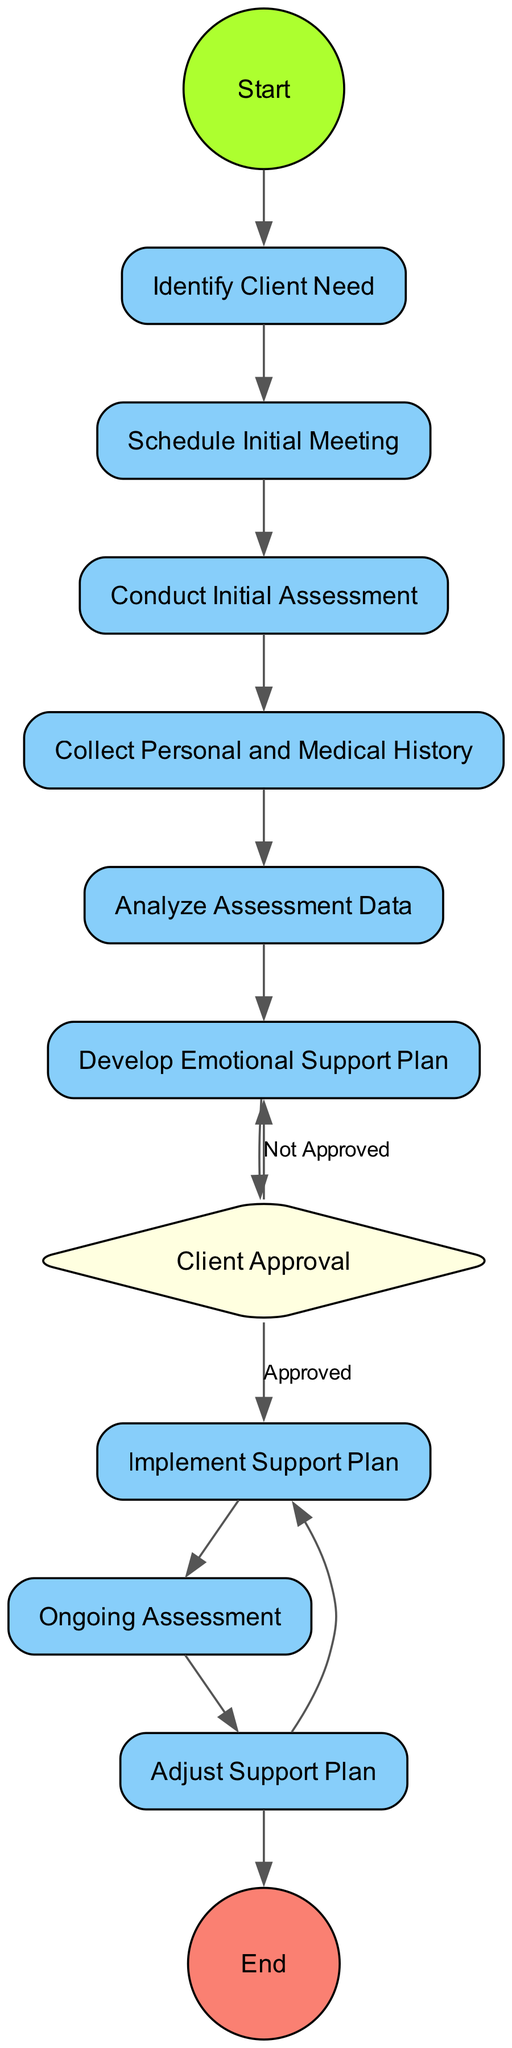What is the first activity in the diagram? The first activity listed in the diagram is "Identify Client Need," which begins the entire process of initial client assessment and emotional support planning.
Answer: Identify Client Need How many action nodes are in the diagram? The diagram contains seven action nodes, which include tasks like scheduling a meeting, conducting assessments, and developing support plans, among others.
Answer: Seven What decision occurs after developing the emotional support plan? After developing the emotional support plan, the decision that occurs is "Client Approval," where the client's consent for the plan is discussed.
Answer: Client Approval What happens if the client does not approve the emotional support plan? If the client does not approve the emotional support plan, the process transitions back to "Develop Emotional Support Plan," where adjustments can be made according to client feedback.
Answer: Develop Emotional Support Plan What activity follows "Ongoing Assessment"? After "Ongoing Assessment," the next activity is "Adjust Support Plan," which indicates that modifications to the support plan are made based on the client's progress.
Answer: Adjust Support Plan What collection of information is done before analyzing assessment data? Before analyzing assessment data, the activity "Collect Personal and Medical History" is performed to gather relevant background information necessary for the analysis.
Answer: Collect Personal and Medical History Which activity leads to implementing the support plan? The activity "Client Approval," where the client's consent is obtained, leads to the implementation of the support plan, provided approval is granted.
Answer: Implement Support Plan How many transitions are there leading to adjustments? There is one transition that leads to adjustments, which comes from "Ongoing Assessment" to "Adjust Support Plan."
Answer: One 